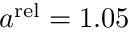Convert formula to latex. <formula><loc_0><loc_0><loc_500><loc_500>a ^ { r e l } = 1 . 0 5</formula> 